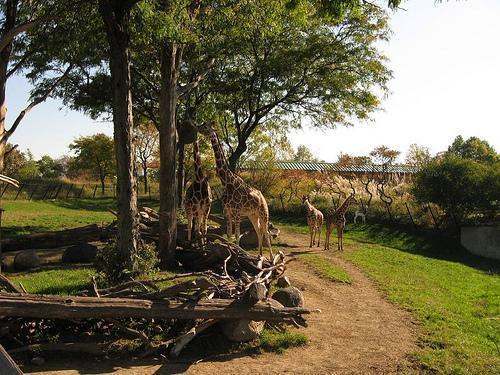How many giraffes are there?
Give a very brief answer. 2. 